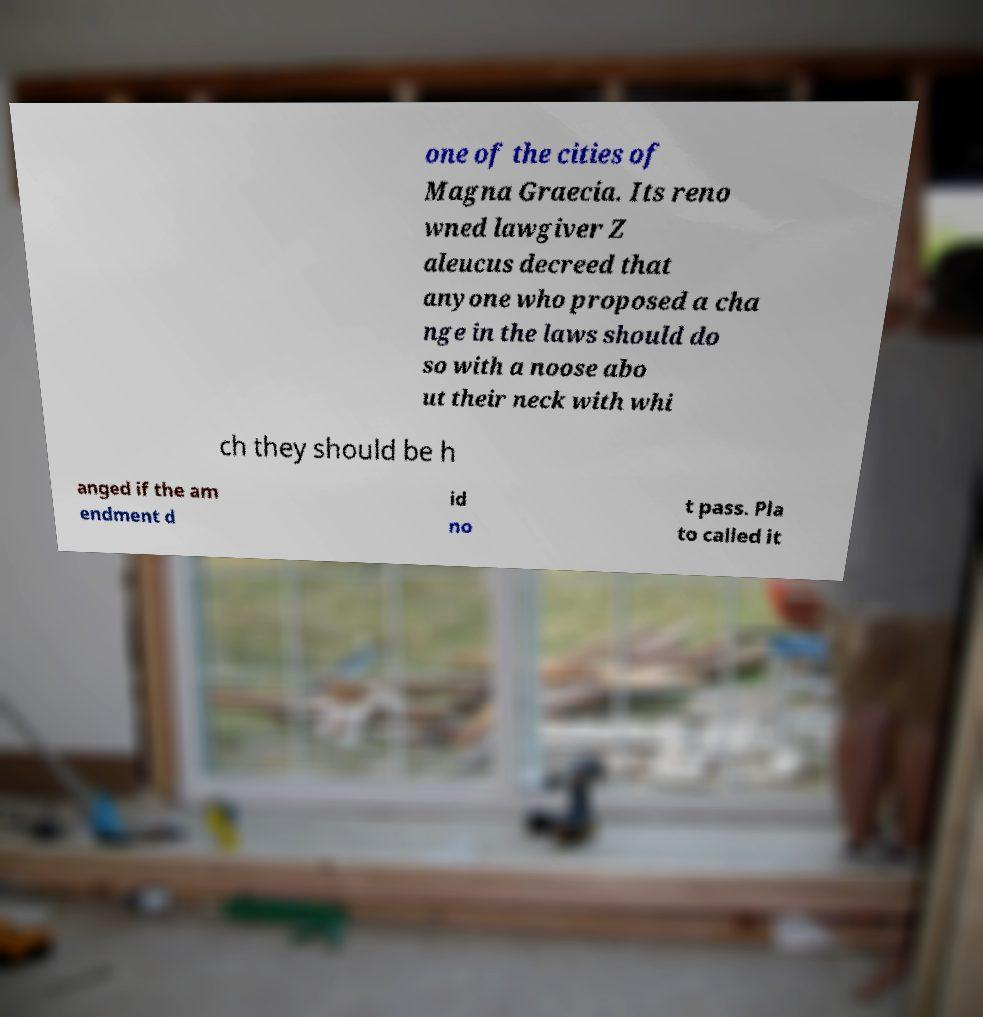Can you accurately transcribe the text from the provided image for me? one of the cities of Magna Graecia. Its reno wned lawgiver Z aleucus decreed that anyone who proposed a cha nge in the laws should do so with a noose abo ut their neck with whi ch they should be h anged if the am endment d id no t pass. Pla to called it 